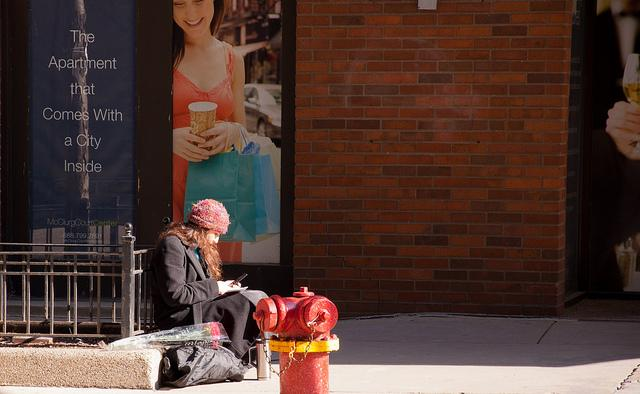What word most closely relates to the red and green things very close to the lady?

Choices:
A) romance
B) power
C) wealth
D) conflict romance 